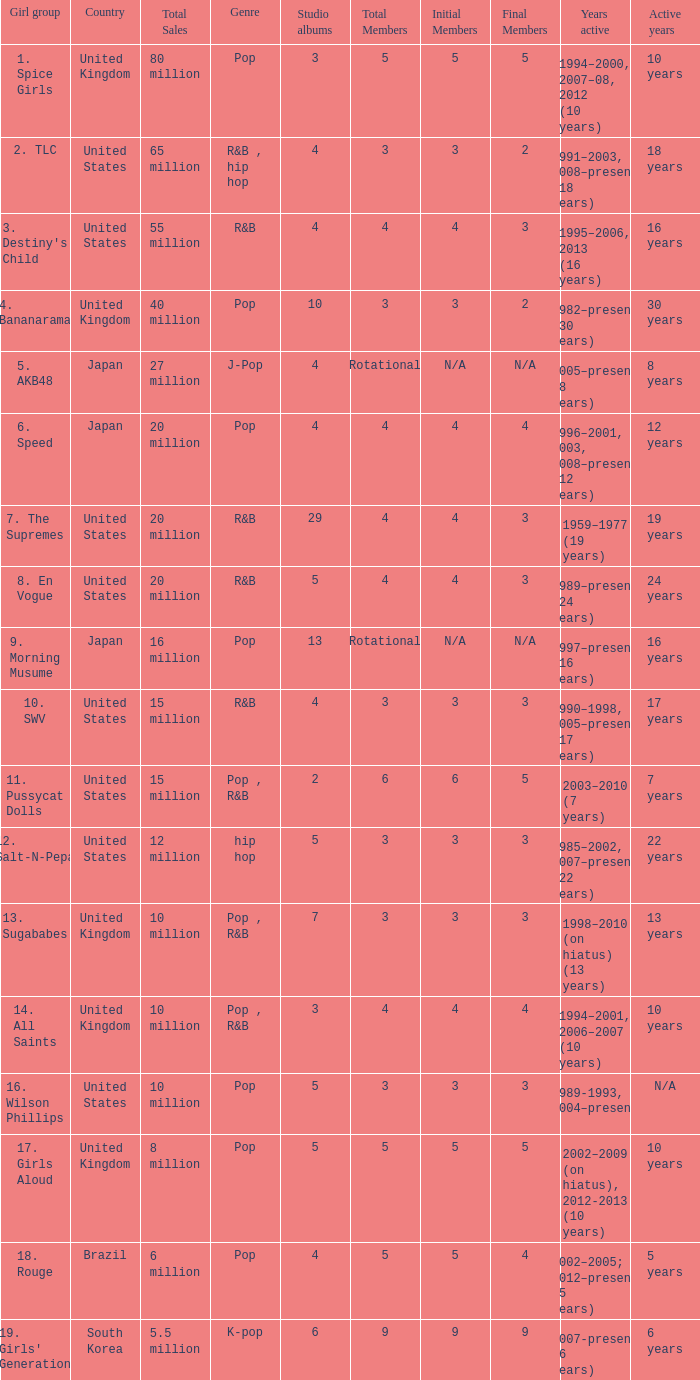What is the count of members in the band that sold 65 million albums and singles? 3 → 2. 